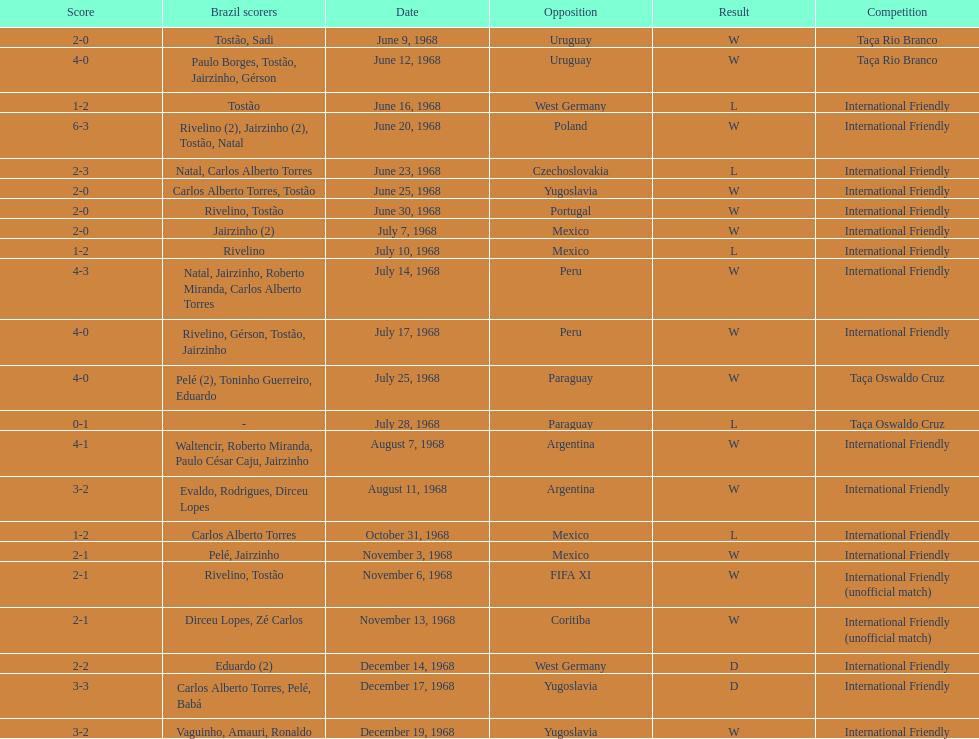How many matches are wins? 15. 